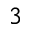Convert formula to latex. <formula><loc_0><loc_0><loc_500><loc_500>_ { 3 }</formula> 